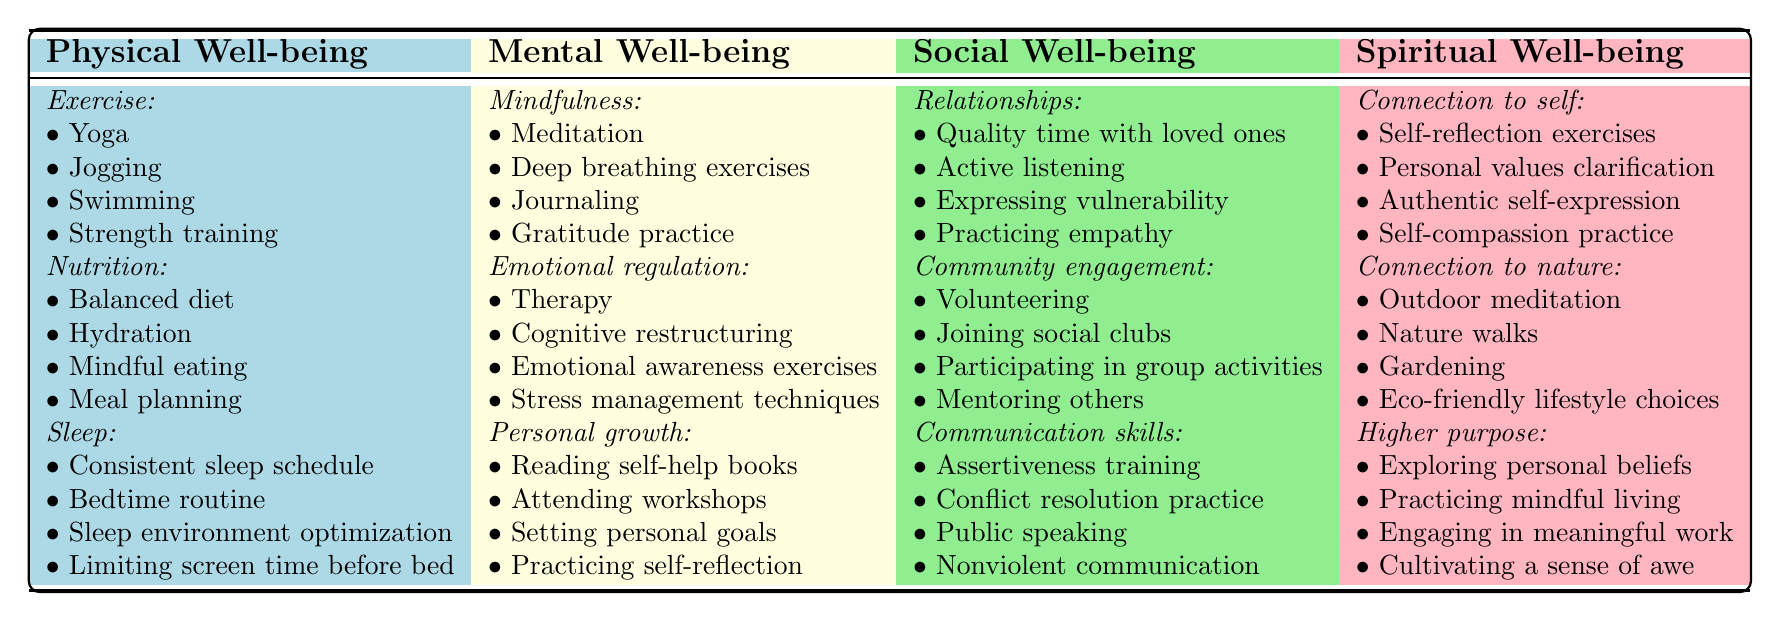What are the self-care practices listed under Physical Well-being? The table shows three categories under Physical Well-being: Exercise, Nutrition, and Sleep. Each category includes specific self-care practices such as Yoga, Balanced diet, and Consistent sleep schedule.
Answer: Exercise, Nutrition, Sleep How many practices are listed under Mental well-being? There are three categories listed under Mental Well-being: Mindfulness, Emotional regulation, and Personal growth. Each category has four practices, so the total number is 3 categories x 4 practices = 12 practices.
Answer: 12 Is "Journaling" included in the table? "Journaling" is listed under the Mindfulness category in the Mental Well-being section, indicating that it is indeed included in the table.
Answer: Yes Which self-care practice appears in both the Social Well-being and Spiritual Well-being sections? Upon examination of the sections, there are no specific self-care practices that are repeated in both Social Well-being and Spiritual Well-being. Each section contains unique practices without overlap.
Answer: No What is the total number of self-care practices listed for Spiritual Well-being? Spiritual Well-being has three subcategories. Each category has four practices, so across all categories, the total is 3 categories x 4 practices = 12 practices.
Answer: 12 Which well-being aspect has the most self-care practices listed and how many? All aspects listed, Physical, Mental, Social, and Spiritual well-being have an equal number of practices, with each containing 12 practices overall (4 in each of 3 categories). Therefore, none is greater than the others.
Answer: None; all equal at 12 Identify one self-care practice from each well-being aspect. Referring to the table, one practice can be selected from each aspect: Yoga from Physical, Meditation from Mental, Quality time with loved ones from Social, and Self-reflection exercises from Spiritual.
Answer: Yoga, Meditation, Quality time with loved ones, Self-reflection exercises What is the total number of self-care practices focused on Emotional regulation? Emotional regulation has four specific practices outlined: Therapy, Cognitive restructuring, Emotional awareness exercises, and Stress management techniques. Hence, the total is 4.
Answer: 4 Which aspect has the fewest number of categories? When reviewing the well-being aspects, all aspects (Physical, Mental, Social, Spiritual) have three categories each, so none has fewer categories than the others.
Answer: None; all have three categories List all the practices related to Community engagement. Under the Community engagement category, the practices listed are Volunteering, Joining social clubs, Participating in group activities, and Mentoring others.
Answer: Volunteering, Joining social clubs, Participating in group activities, Mentoring others 